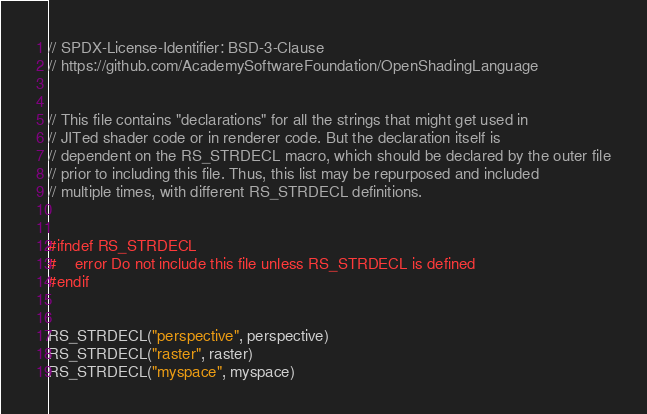<code> <loc_0><loc_0><loc_500><loc_500><_C_>// SPDX-License-Identifier: BSD-3-Clause
// https://github.com/AcademySoftwareFoundation/OpenShadingLanguage


// This file contains "declarations" for all the strings that might get used in
// JITed shader code or in renderer code. But the declaration itself is
// dependent on the RS_STRDECL macro, which should be declared by the outer file
// prior to including this file. Thus, this list may be repurposed and included
// multiple times, with different RS_STRDECL definitions.


#ifndef RS_STRDECL
#    error Do not include this file unless RS_STRDECL is defined
#endif


RS_STRDECL("perspective", perspective)
RS_STRDECL("raster", raster)
RS_STRDECL("myspace", myspace)</code> 